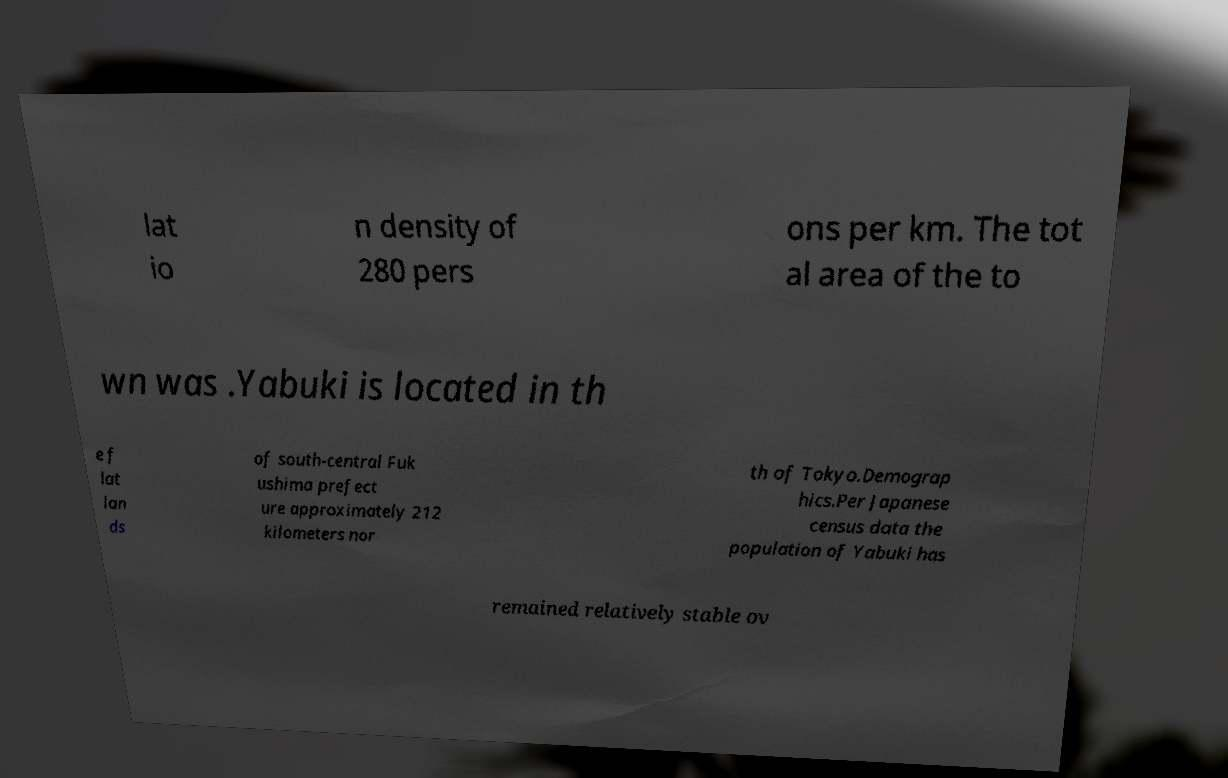Can you read and provide the text displayed in the image?This photo seems to have some interesting text. Can you extract and type it out for me? lat io n density of 280 pers ons per km. The tot al area of the to wn was .Yabuki is located in th e f lat lan ds of south-central Fuk ushima prefect ure approximately 212 kilometers nor th of Tokyo.Demograp hics.Per Japanese census data the population of Yabuki has remained relatively stable ov 